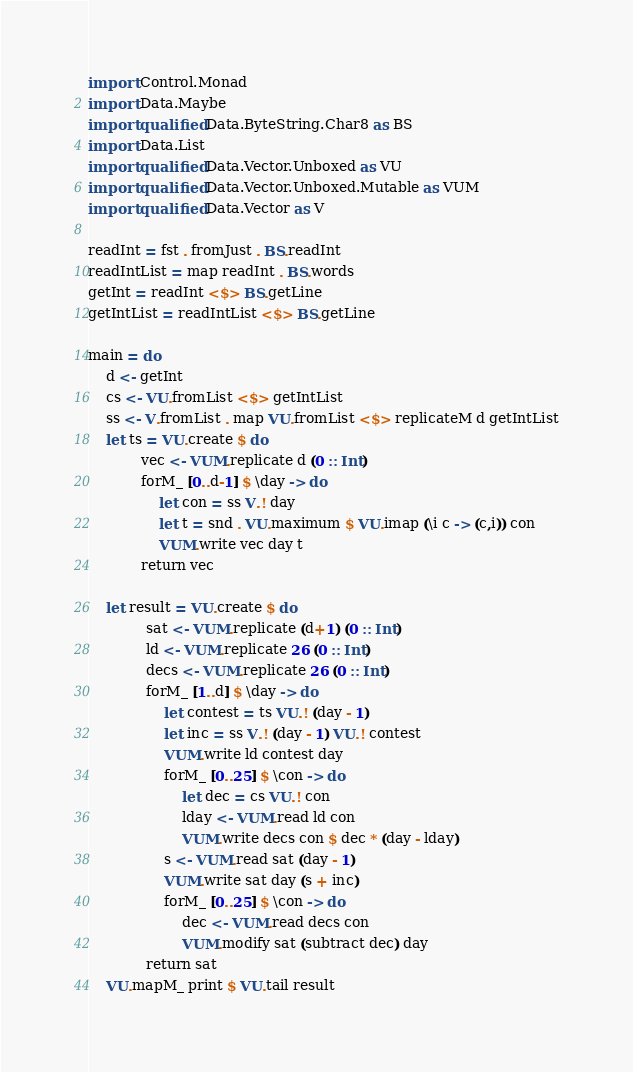Convert code to text. <code><loc_0><loc_0><loc_500><loc_500><_Haskell_>import Control.Monad
import Data.Maybe
import qualified Data.ByteString.Char8 as BS
import Data.List
import qualified Data.Vector.Unboxed as VU
import qualified Data.Vector.Unboxed.Mutable as VUM
import qualified Data.Vector as V

readInt = fst . fromJust . BS.readInt
readIntList = map readInt . BS.words
getInt = readInt <$> BS.getLine
getIntList = readIntList <$> BS.getLine

main = do
    d <- getInt
    cs <- VU.fromList <$> getIntList
    ss <- V.fromList . map VU.fromList <$> replicateM d getIntList
    let ts = VU.create $ do
            vec <- VUM.replicate d (0 :: Int)
            forM_ [0..d-1] $ \day -> do
                let con = ss V.! day
                let t = snd . VU.maximum $ VU.imap (\i c -> (c,i)) con
                VUM.write vec day t
            return vec
              
    let result = VU.create $ do
             sat <- VUM.replicate (d+1) (0 :: Int)
             ld <- VUM.replicate 26 (0 :: Int)
             decs <- VUM.replicate 26 (0 :: Int)
             forM_ [1..d] $ \day -> do
                 let contest = ts VU.! (day - 1)
                 let inc = ss V.! (day - 1) VU.! contest
                 VUM.write ld contest day
                 forM_ [0..25] $ \con -> do
                     let dec = cs VU.! con
                     lday <- VUM.read ld con
                     VUM.write decs con $ dec * (day - lday)
                 s <- VUM.read sat (day - 1)
                 VUM.write sat day (s + inc)
                 forM_ [0..25] $ \con -> do
                     dec <- VUM.read decs con
                     VUM.modify sat (subtract dec) day
             return sat
    VU.mapM_ print $ VU.tail result</code> 